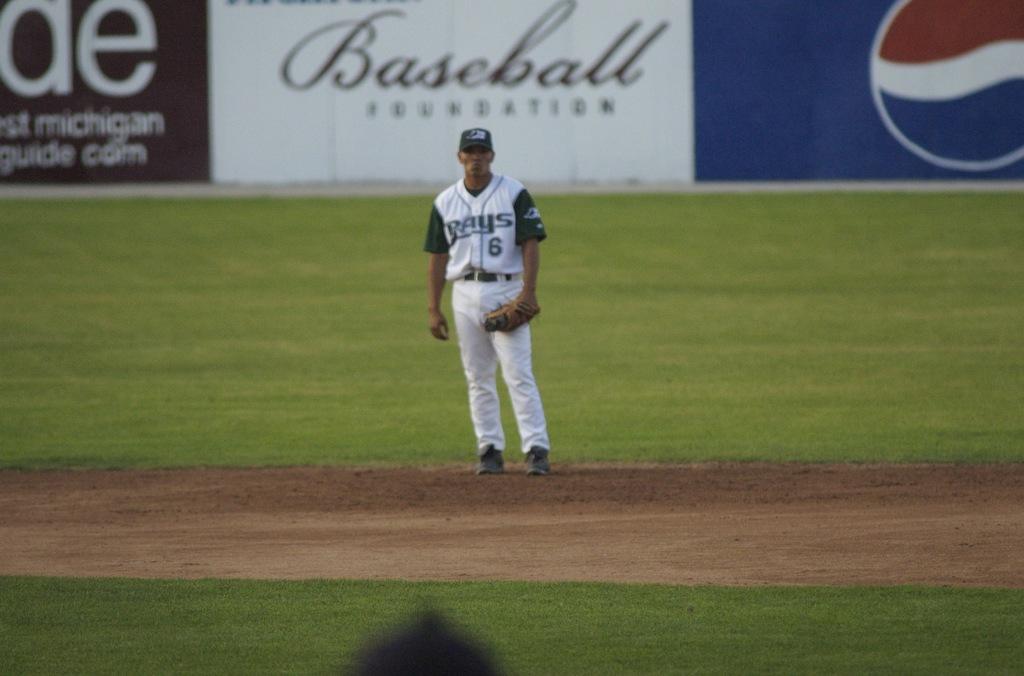What team does he represent?
Give a very brief answer. Rays. 